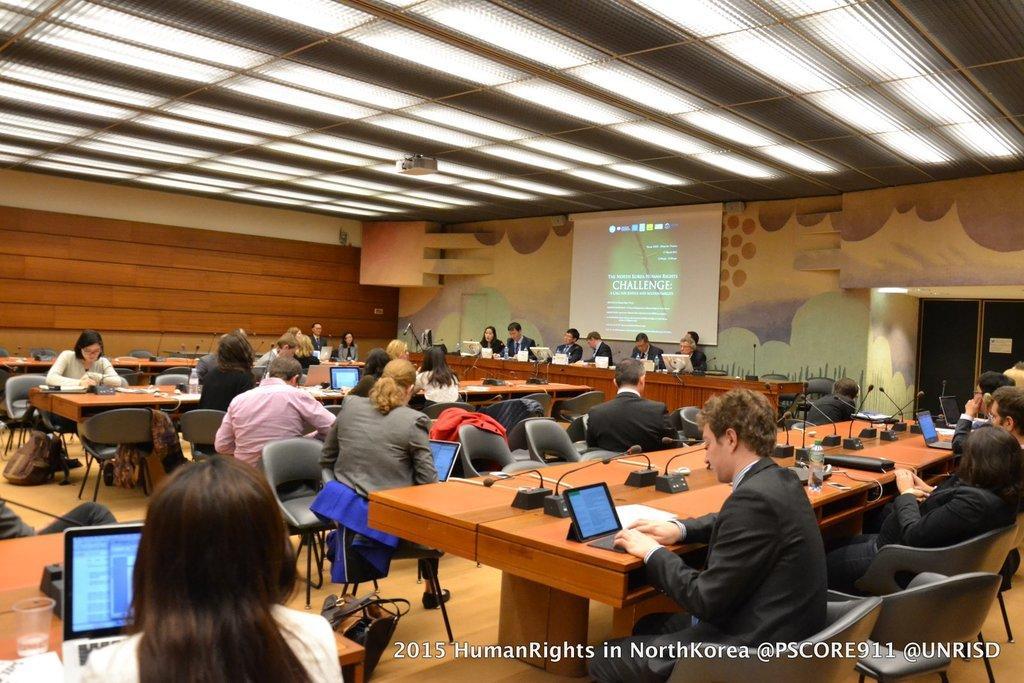How would you summarize this image in a sentence or two? In the image we can see group of persons were sitting on the chair around the table. On table,we can see laptop,mouse,water bottle,microphone,wire and glass. In the background there is a wall,door and light. 